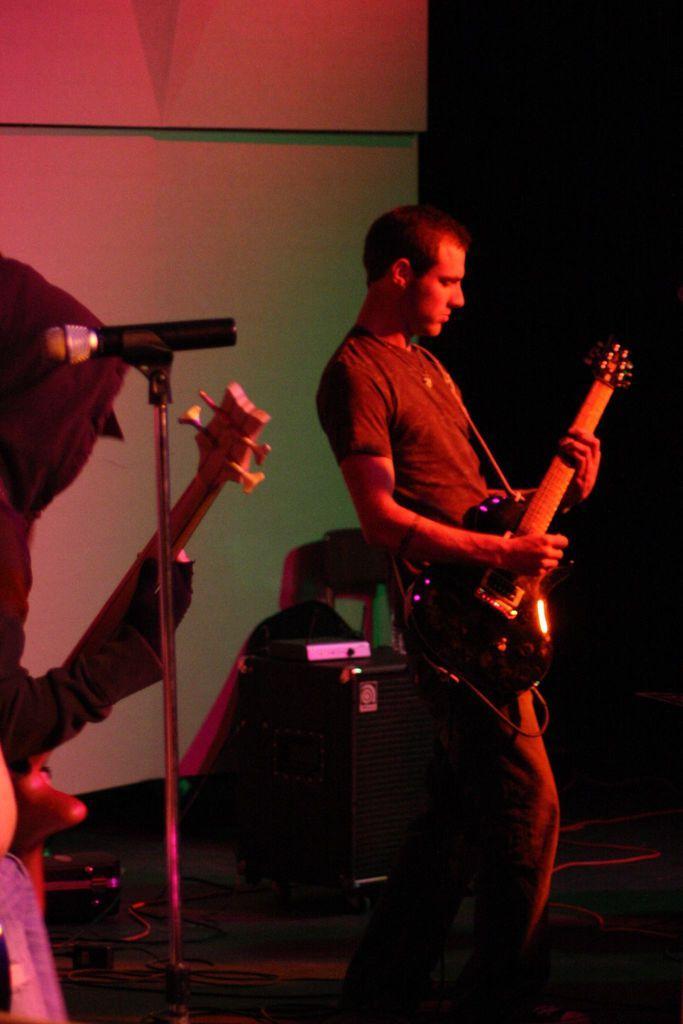In one or two sentences, can you explain what this image depicts? In this picture we can see few people are playing musical instruments and also we can see a microphone. 